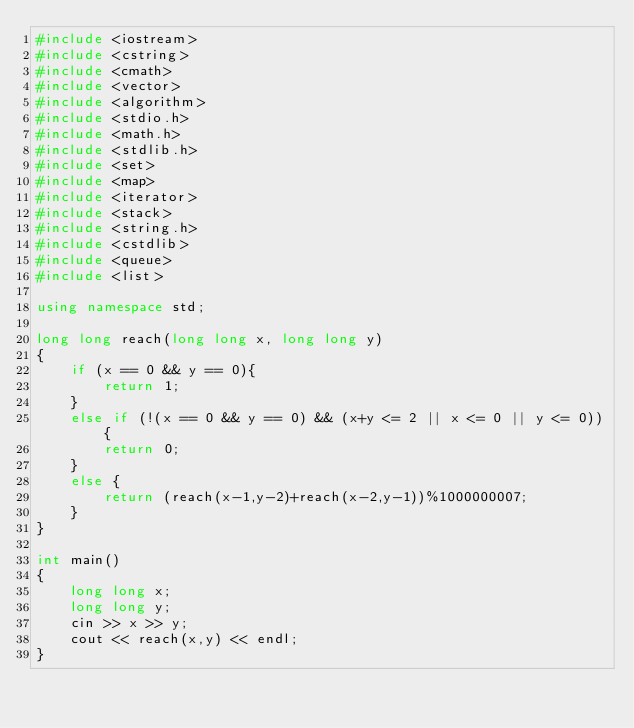<code> <loc_0><loc_0><loc_500><loc_500><_C++_>#include <iostream>
#include <cstring>
#include <cmath>
#include <vector>
#include <algorithm>
#include <stdio.h>
#include <math.h>
#include <stdlib.h>
#include <set>
#include <map>
#include <iterator>
#include <stack>
#include <string.h>
#include <cstdlib>
#include <queue>
#include <list>

using namespace std;

long long reach(long long x, long long y)
{
    if (x == 0 && y == 0){
        return 1;
    }
    else if (!(x == 0 && y == 0) && (x+y <= 2 || x <= 0 || y <= 0)){
        return 0;
    }
    else {
        return (reach(x-1,y-2)+reach(x-2,y-1))%1000000007;
    }
}

int main()
{
    long long x;
    long long y;
    cin >> x >> y;
    cout << reach(x,y) << endl;
}
</code> 